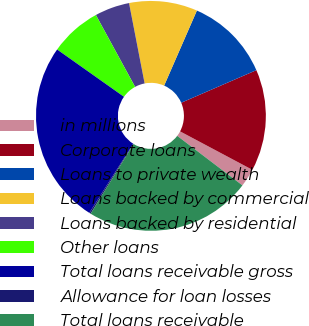<chart> <loc_0><loc_0><loc_500><loc_500><pie_chart><fcel>in millions<fcel>Corporate loans<fcel>Loans to private wealth<fcel>Loans backed by commercial<fcel>Loans backed by residential<fcel>Other loans<fcel>Total loans receivable gross<fcel>Allowance for loan losses<fcel>Total loans receivable<nl><fcel>2.56%<fcel>14.29%<fcel>11.94%<fcel>9.6%<fcel>4.9%<fcel>7.25%<fcel>25.8%<fcel>0.21%<fcel>23.45%<nl></chart> 